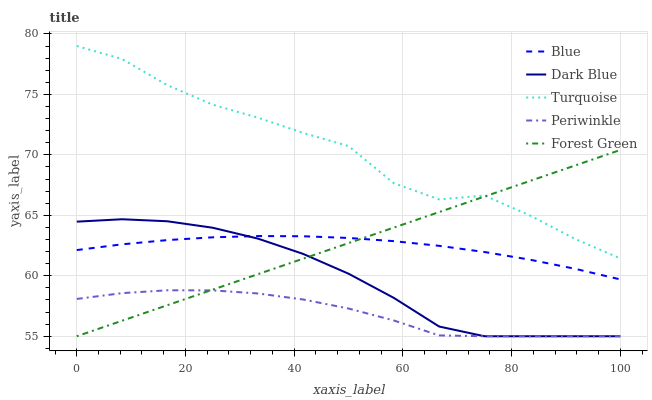Does Dark Blue have the minimum area under the curve?
Answer yes or no. No. Does Dark Blue have the maximum area under the curve?
Answer yes or no. No. Is Dark Blue the smoothest?
Answer yes or no. No. Is Dark Blue the roughest?
Answer yes or no. No. Does Turquoise have the lowest value?
Answer yes or no. No. Does Dark Blue have the highest value?
Answer yes or no. No. Is Blue less than Turquoise?
Answer yes or no. Yes. Is Blue greater than Periwinkle?
Answer yes or no. Yes. Does Blue intersect Turquoise?
Answer yes or no. No. 